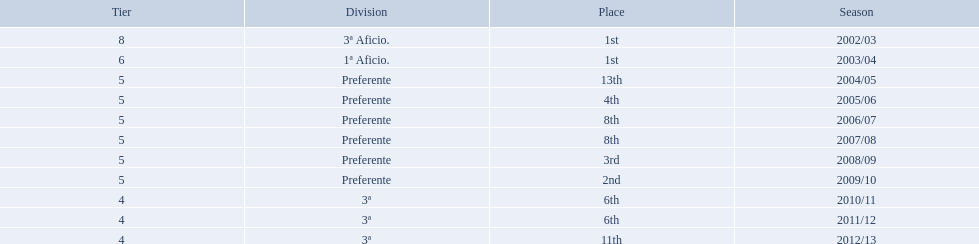What place did the team place in 2010/11? 6th. In what other year did they place 6th? 2011/12. 